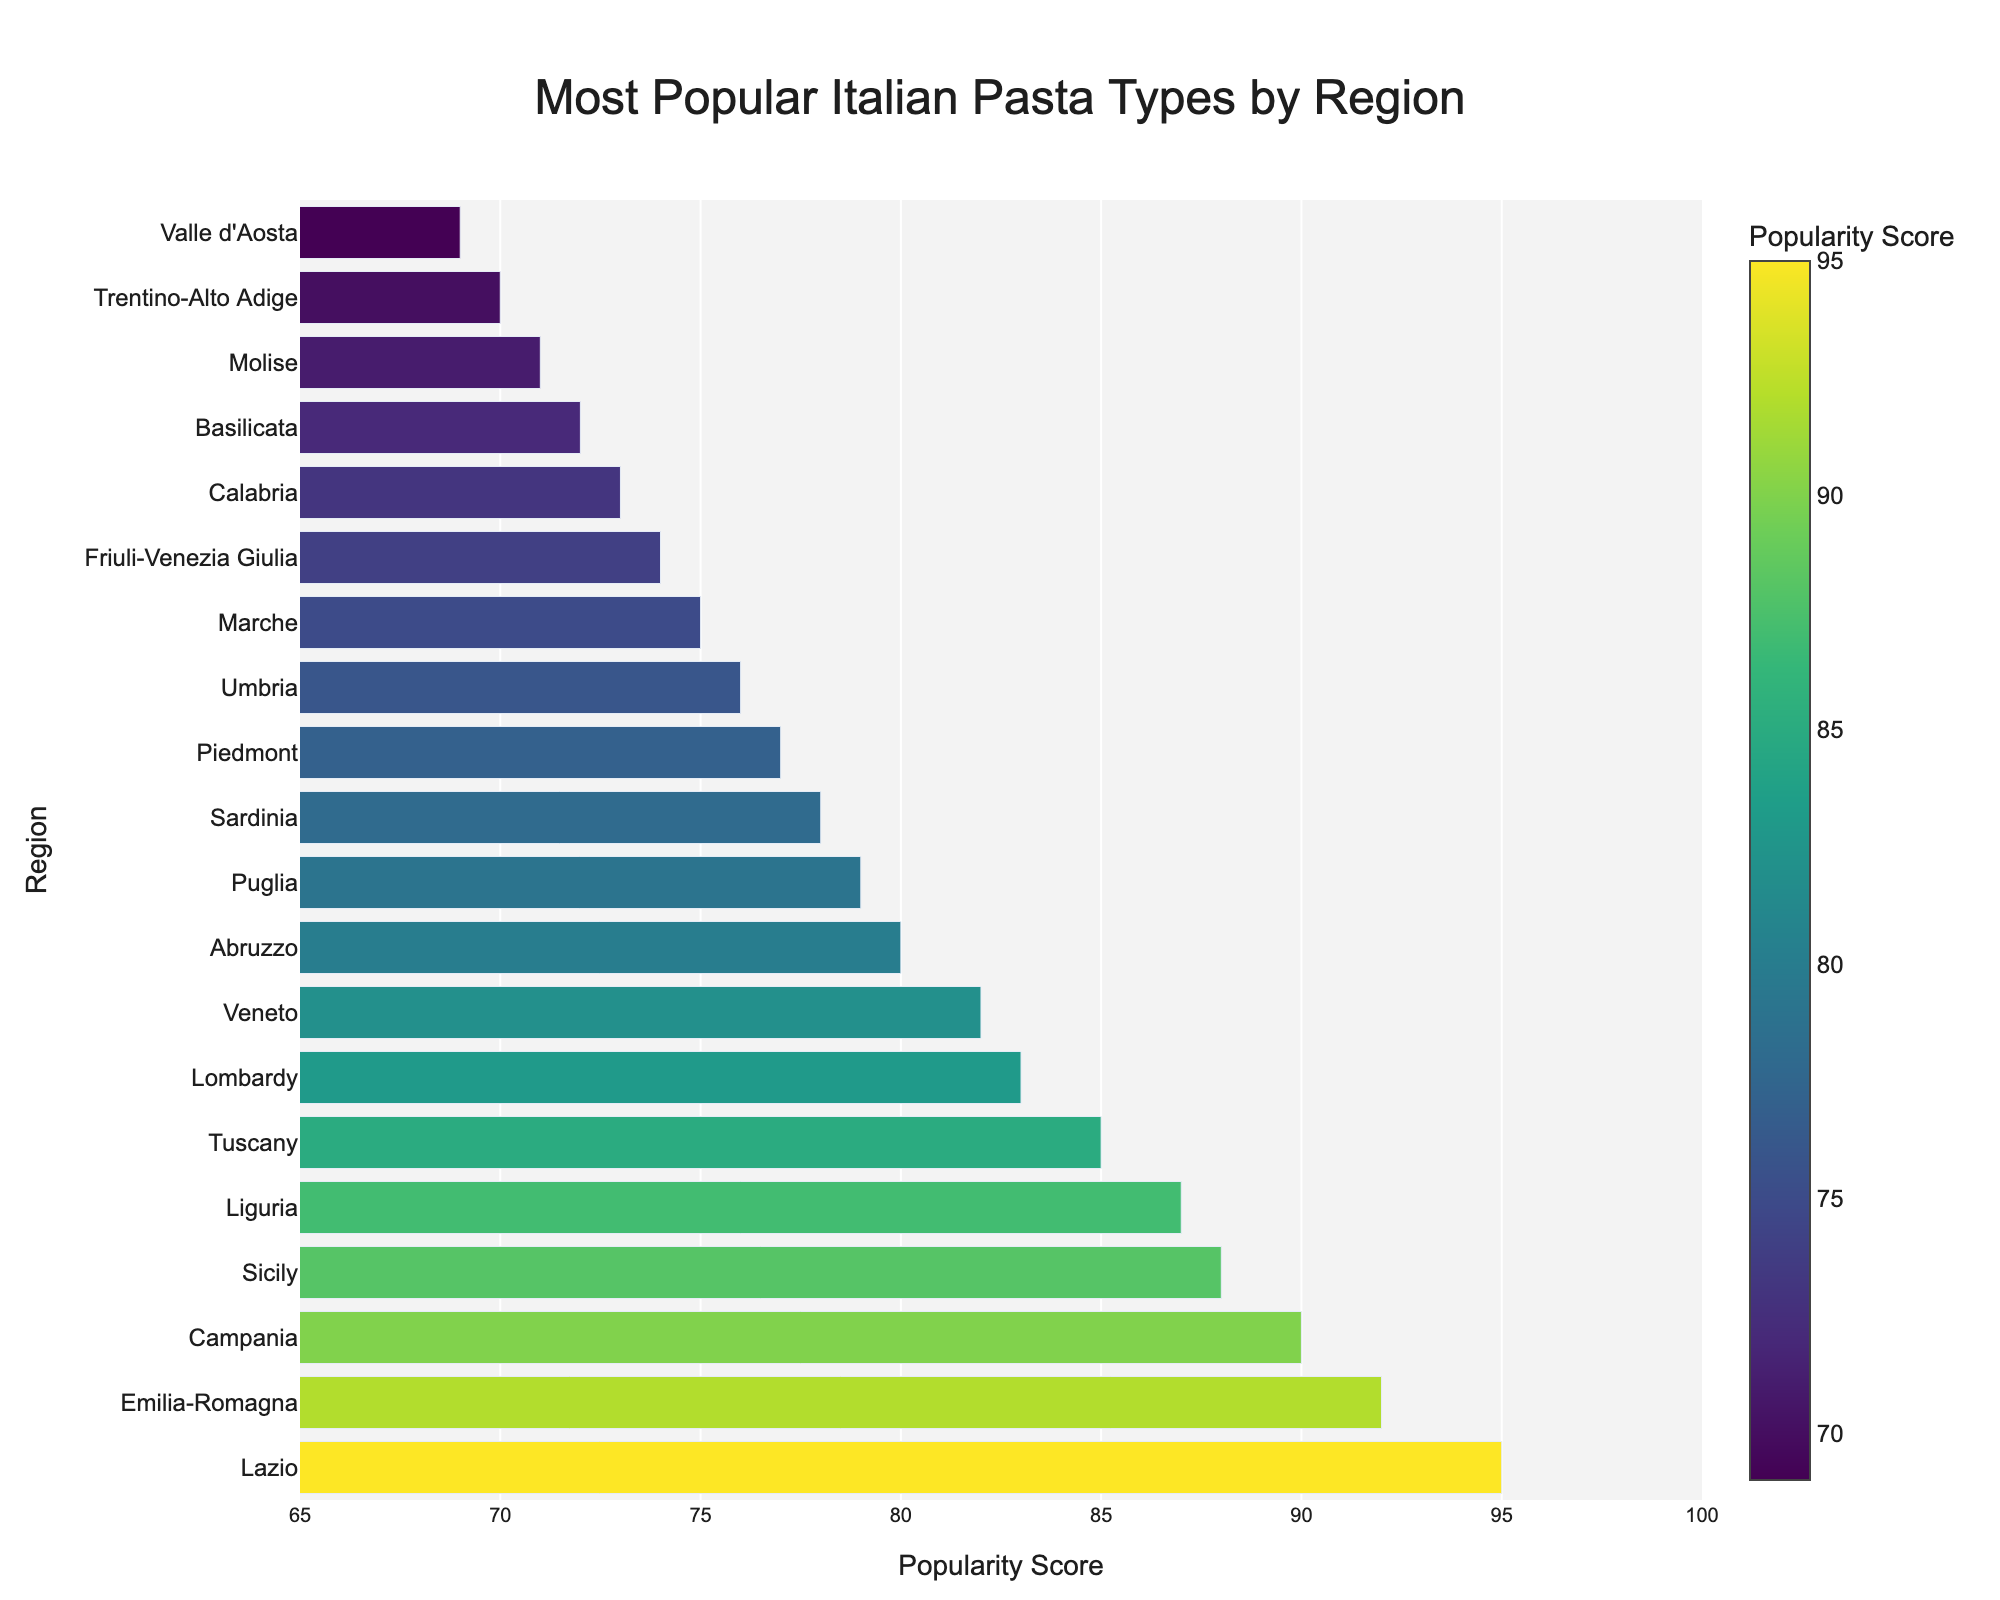What is the most popular Italian pasta type by region? To determine the most popular Italian pasta type by region, look for the bar with the highest popularity score. The highest bar represents Lazio, with a score of 95. The pasta type listed for this region is Spaghetti alla Carbonara.
Answer: Spaghetti alla Carbonara Which region has the lowest popularity score for its pasta type? To find the region with the lowest popularity score, identify the bar with the shortest height. The shortest bar represents Valle d'Aosta, with a popularity score of 69.
Answer: Valle d'Aosta How does Emilia-Romagna's popularity score compare to Campania's? To compare the popularity scores of different regions, locate and check their respective heights. Emilia-Romagna has a popularity score of 92, whereas Campania has 90. Hence, Emilia-Romagna's score is higher by 2 points.
Answer: Emilia-Romagna's score is higher Calculate the difference in popularity score between Tuscany (Pappardelle al Cinghiale) and Veneto (Bigoli in Salsa). Locate the bars representing Tuscany and Veneto. Tuscany has a popularity score of 85 and Veneto has 82. The difference is 85 - 82 = 3.
Answer: 3 What is the average popularity score of the pasta types listed in the figure? To find the average, sum all the popularity scores and divide by the number of regions. The scores are: 95, 92, 90, 88, 87, 85, 83, 82, 80, 79, 78, 77, 76, 75, 74, 73, 72, 71, 70, 69. The sum is 1563. There are 20 regions, so the average score is 1563 / 20 = 78.15.
Answer: 78.15 Which pasta type is more popular: Trofie al Pesto or Vincisgrassi? Look at the popularity scores of Liguria (Trofie al Pesto) and Marche (Vincisgrassi). Trofie al Pesto has a score of 87, whereas Vincisgrassi has 75. Since 87 > 75, Trofie al Pesto is more popular.
Answer: Trofie al Pesto What's the median popularity score of pasta types in the figure? Arrange the scores in order and find the middle value. The scores in order are 69, 70, 71, 72, 73, 74, 75, 76, 77, 78, 79, 80, 82, 83, 85, 87, 88, 90, 92, 95. Since there are 20 scores, the median is the average of the 10th and 11th scores: (78+79)/2 = 78.5.
Answer: 78.5 How many regions have a pasta popularity score above 80? Count the number of bars with a popularity score greater than 80. The regions and their scores above 80 are Lazio (95), Emilia-Romagna (92), Campania (90), Sicily (88), Liguria (87), Tuscany (85), Lombardy (83), and Veneto (82). There are 8 such regions.
Answer: 8 What color does the bar representing Abruzzo (Spaghetti alla Chitarra) likely have compared to the bar representing Sicily (Pasta alla Norma), considering the color scale used? Abruzzo has a score of 80 and Sicily has 88. On a Viridis color scale, higher scores are represented by brighter colors. Thus, Sicily's bar will appear brighter compared to Abruzzo's bar.
Answer: Sicily's bar is brighter 